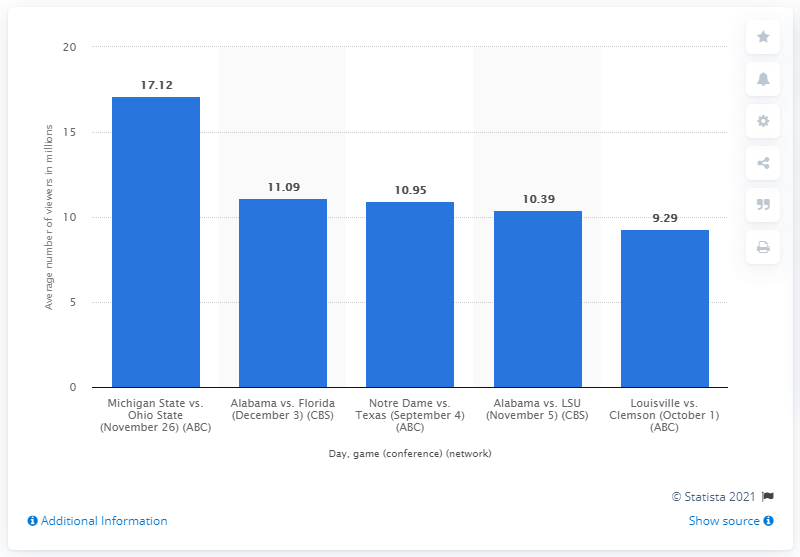Outline some significant characteristics in this image. According to the data, the average number of viewers who watched the Michigan State vs Ohio State game was 17.12. 